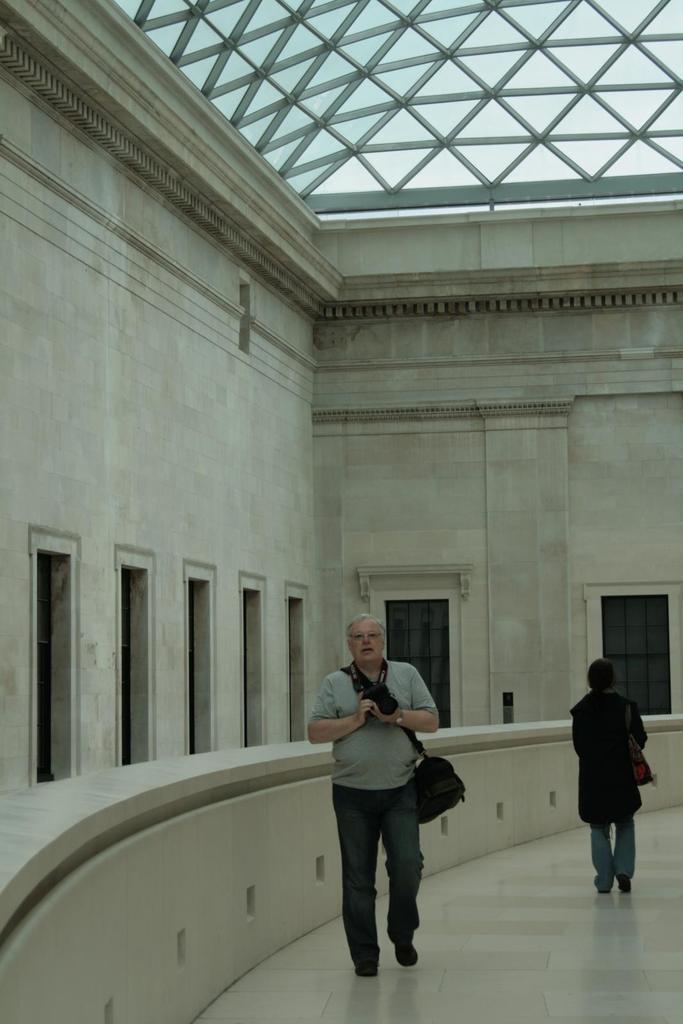Please provide a concise description of this image. As we can see in the image there is a building, windows and two persons walking over here. 